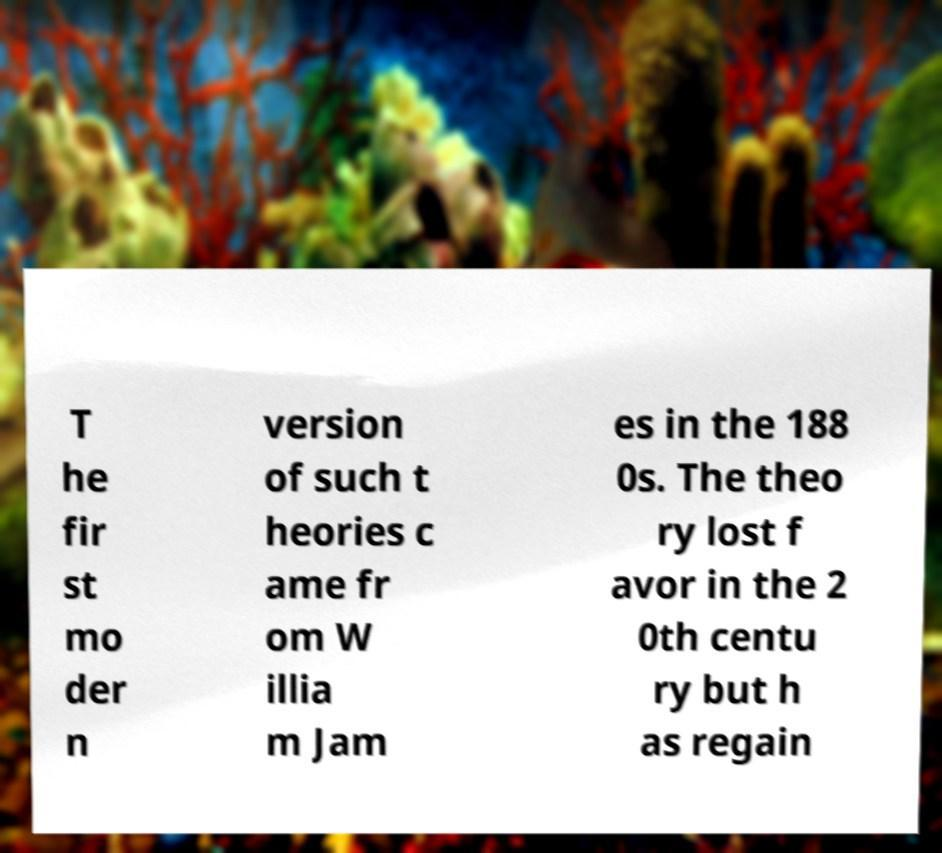What messages or text are displayed in this image? I need them in a readable, typed format. T he fir st mo der n version of such t heories c ame fr om W illia m Jam es in the 188 0s. The theo ry lost f avor in the 2 0th centu ry but h as regain 